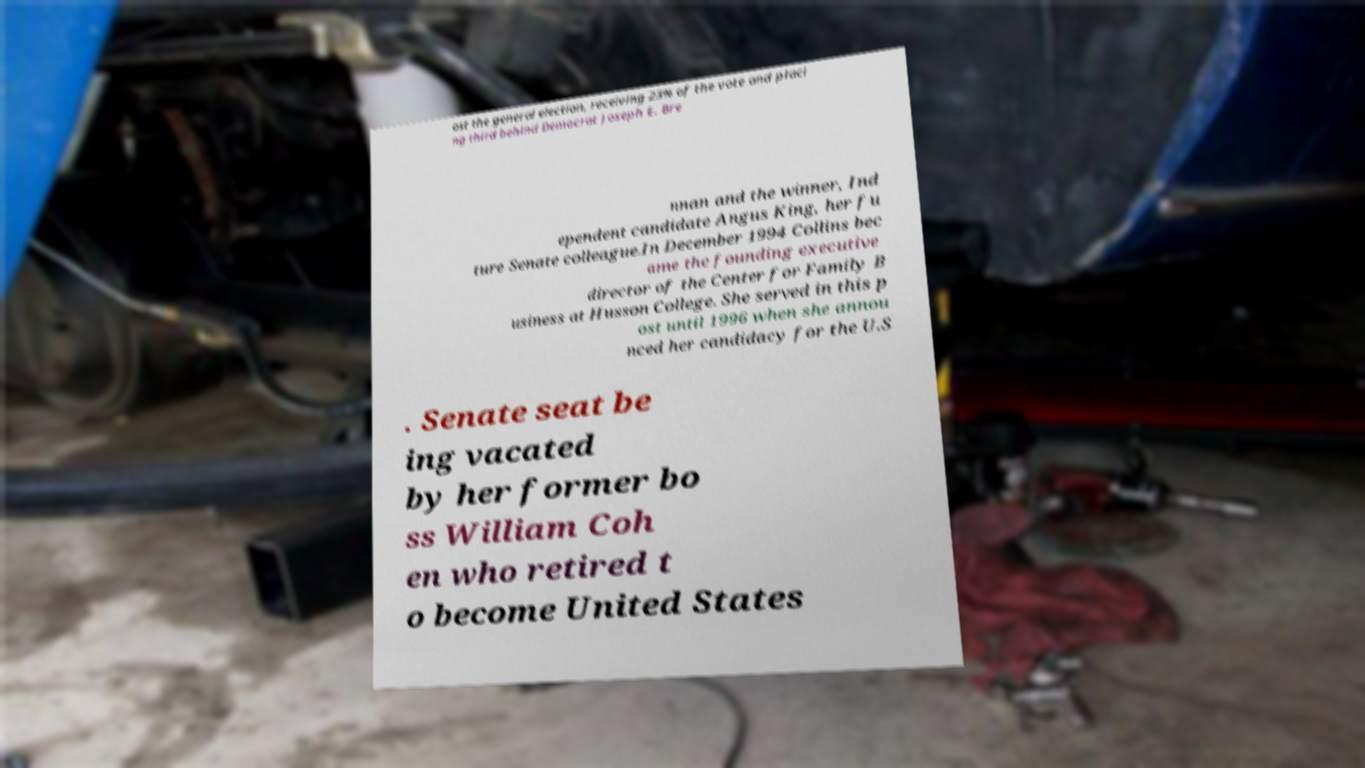What messages or text are displayed in this image? I need them in a readable, typed format. ost the general election, receiving 23% of the vote and placi ng third behind Democrat Joseph E. Bre nnan and the winner, Ind ependent candidate Angus King, her fu ture Senate colleague.In December 1994 Collins bec ame the founding executive director of the Center for Family B usiness at Husson College. She served in this p ost until 1996 when she annou nced her candidacy for the U.S . Senate seat be ing vacated by her former bo ss William Coh en who retired t o become United States 